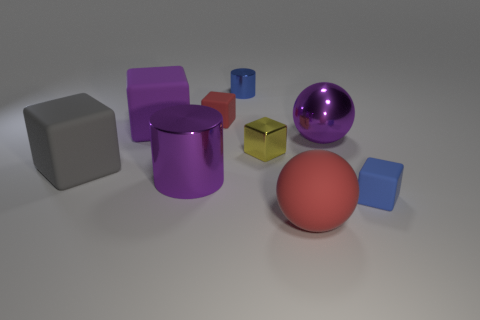There is a object that is right of the tiny metal block and behind the blue cube; what color is it?
Give a very brief answer. Purple. The blue cube has what size?
Ensure brevity in your answer.  Small. How many matte things are the same size as the purple metallic ball?
Your answer should be compact. 3. Does the blue object that is in front of the yellow shiny cube have the same material as the cylinder that is left of the tiny blue metal cylinder?
Make the answer very short. No. What material is the red thing right of the small blue thing on the left side of the small blue rubber thing made of?
Your answer should be compact. Rubber. There is a purple thing in front of the gray object; what material is it?
Your answer should be very brief. Metal. How many big metallic objects are the same shape as the large purple rubber object?
Keep it short and to the point. 0. Is the metallic sphere the same color as the large cylinder?
Your answer should be very brief. Yes. The red ball that is on the right side of the large cylinder to the left of the metallic cylinder behind the yellow cube is made of what material?
Provide a short and direct response. Rubber. There is a purple sphere; are there any cubes in front of it?
Your answer should be compact. Yes. 